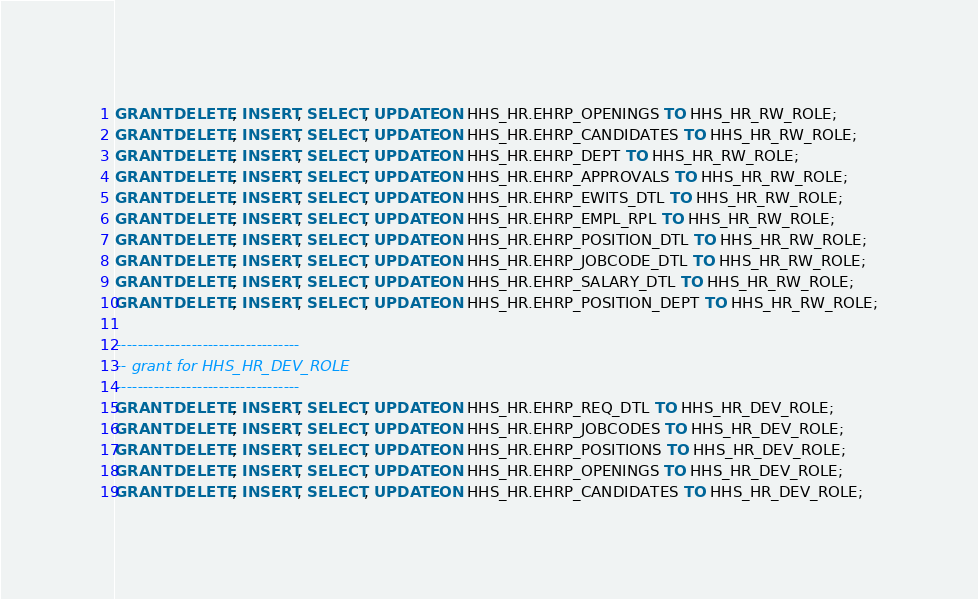<code> <loc_0><loc_0><loc_500><loc_500><_SQL_>GRANT DELETE, INSERT, SELECT, UPDATE ON HHS_HR.EHRP_OPENINGS TO HHS_HR_RW_ROLE;
GRANT DELETE, INSERT, SELECT, UPDATE ON HHS_HR.EHRP_CANDIDATES TO HHS_HR_RW_ROLE;
GRANT DELETE, INSERT, SELECT, UPDATE ON HHS_HR.EHRP_DEPT TO HHS_HR_RW_ROLE;
GRANT DELETE, INSERT, SELECT, UPDATE ON HHS_HR.EHRP_APPROVALS TO HHS_HR_RW_ROLE;
GRANT DELETE, INSERT, SELECT, UPDATE ON HHS_HR.EHRP_EWITS_DTL TO HHS_HR_RW_ROLE;
GRANT DELETE, INSERT, SELECT, UPDATE ON HHS_HR.EHRP_EMPL_RPL TO HHS_HR_RW_ROLE;
GRANT DELETE, INSERT, SELECT, UPDATE ON HHS_HR.EHRP_POSITION_DTL TO HHS_HR_RW_ROLE;
GRANT DELETE, INSERT, SELECT, UPDATE ON HHS_HR.EHRP_JOBCODE_DTL TO HHS_HR_RW_ROLE;
GRANT DELETE, INSERT, SELECT, UPDATE ON HHS_HR.EHRP_SALARY_DTL TO HHS_HR_RW_ROLE;
GRANT DELETE, INSERT, SELECT, UPDATE ON HHS_HR.EHRP_POSITION_DEPT TO HHS_HR_RW_ROLE;

----------------------------------
-- grant for HHS_HR_DEV_ROLE
----------------------------------
GRANT DELETE, INSERT, SELECT, UPDATE ON HHS_HR.EHRP_REQ_DTL TO HHS_HR_DEV_ROLE;
GRANT DELETE, INSERT, SELECT, UPDATE ON HHS_HR.EHRP_JOBCODES TO HHS_HR_DEV_ROLE;
GRANT DELETE, INSERT, SELECT, UPDATE ON HHS_HR.EHRP_POSITIONS TO HHS_HR_DEV_ROLE;
GRANT DELETE, INSERT, SELECT, UPDATE ON HHS_HR.EHRP_OPENINGS TO HHS_HR_DEV_ROLE;
GRANT DELETE, INSERT, SELECT, UPDATE ON HHS_HR.EHRP_CANDIDATES TO HHS_HR_DEV_ROLE;</code> 